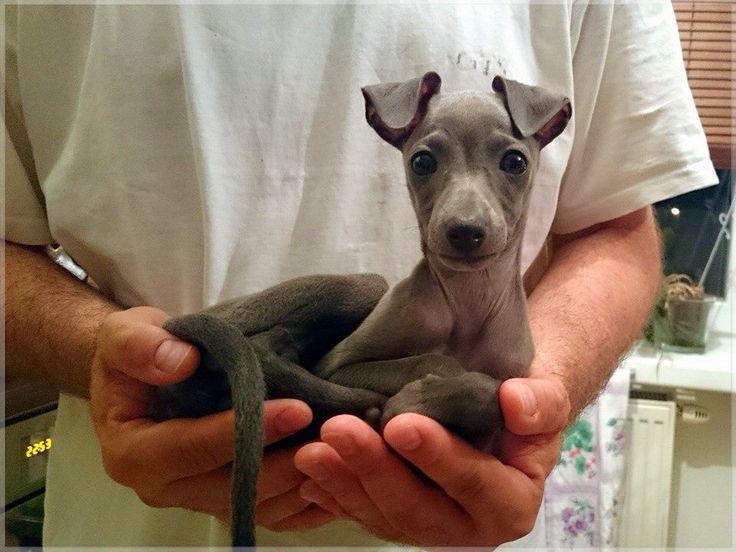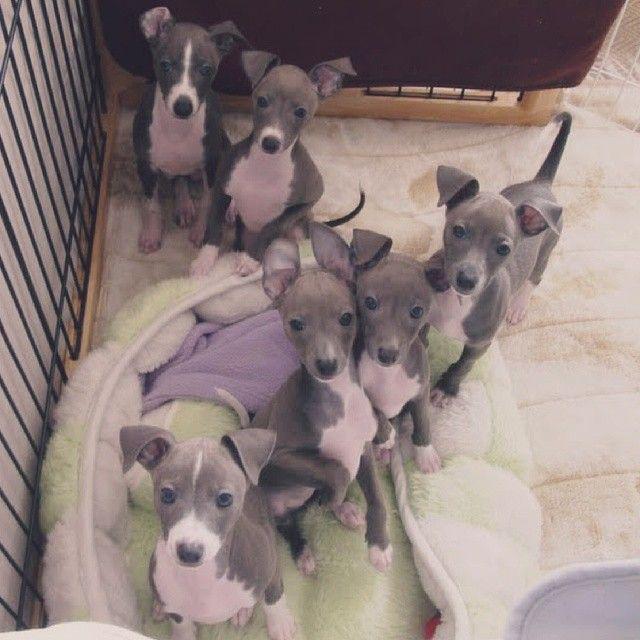The first image is the image on the left, the second image is the image on the right. For the images displayed, is the sentence "There is at least five dogs." factually correct? Answer yes or no. Yes. The first image is the image on the left, the second image is the image on the right. Considering the images on both sides, is "A person is holding the dog in the image on the left." valid? Answer yes or no. Yes. 